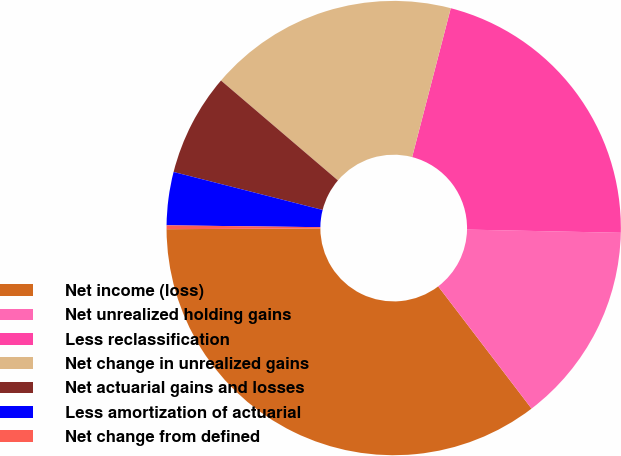Convert chart. <chart><loc_0><loc_0><loc_500><loc_500><pie_chart><fcel>Net income (loss)<fcel>Net unrealized holding gains<fcel>Less reclassification<fcel>Net change in unrealized gains<fcel>Net actuarial gains and losses<fcel>Less amortization of actuarial<fcel>Net change from defined<nl><fcel>35.3%<fcel>14.29%<fcel>21.29%<fcel>17.79%<fcel>7.28%<fcel>3.78%<fcel>0.27%<nl></chart> 